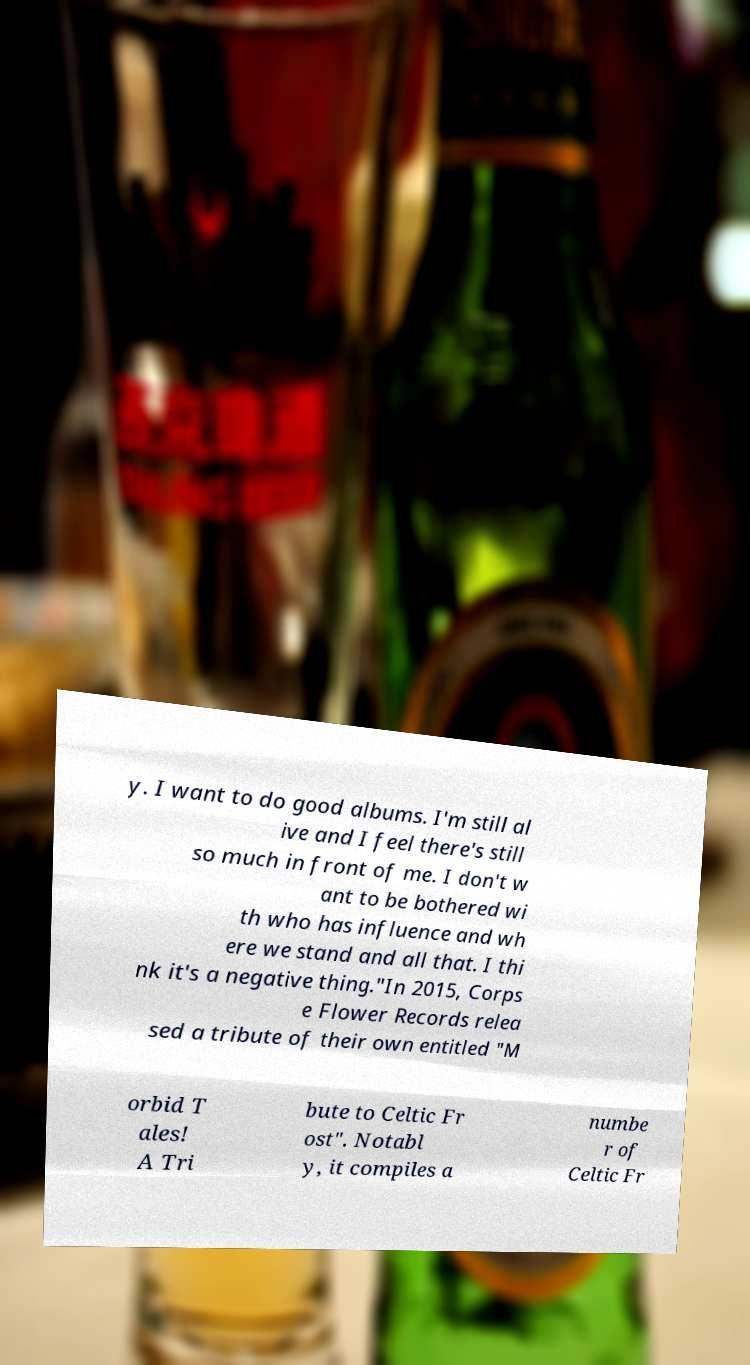There's text embedded in this image that I need extracted. Can you transcribe it verbatim? y. I want to do good albums. I'm still al ive and I feel there's still so much in front of me. I don't w ant to be bothered wi th who has influence and wh ere we stand and all that. I thi nk it's a negative thing."In 2015, Corps e Flower Records relea sed a tribute of their own entitled "M orbid T ales! A Tri bute to Celtic Fr ost". Notabl y, it compiles a numbe r of Celtic Fr 